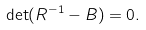Convert formula to latex. <formula><loc_0><loc_0><loc_500><loc_500>\det ( R ^ { - 1 } - B ) = 0 .</formula> 